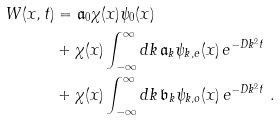Convert formula to latex. <formula><loc_0><loc_0><loc_500><loc_500>W ( x , t ) & = \mathfrak { a } _ { 0 } \chi ( x ) \psi _ { 0 } ( x ) \\ & + \chi ( x ) \int _ { - \infty } ^ { \infty } d k \, \mathfrak { a } _ { k } \psi _ { k , e } ( x ) \, e ^ { - D k ^ { 2 } t } \\ & + \chi ( x ) \int _ { - \infty } ^ { \infty } d k \, \mathfrak { b } _ { k } \psi _ { k , o } ( x ) \, e ^ { - D k ^ { 2 } t } \ .</formula> 